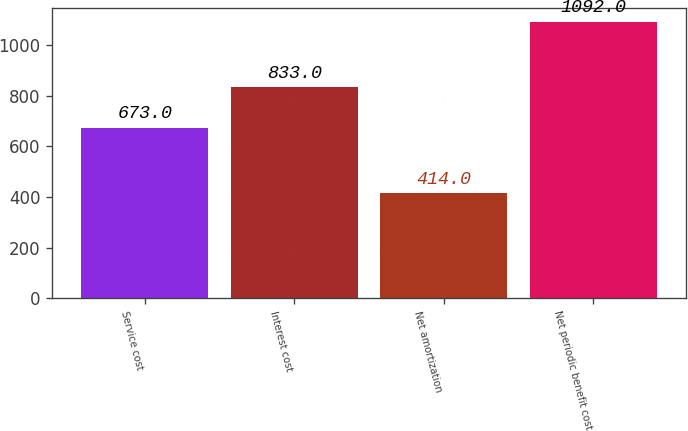<chart> <loc_0><loc_0><loc_500><loc_500><bar_chart><fcel>Service cost<fcel>Interest cost<fcel>Net amortization<fcel>Net periodic benefit cost<nl><fcel>673<fcel>833<fcel>414<fcel>1092<nl></chart> 